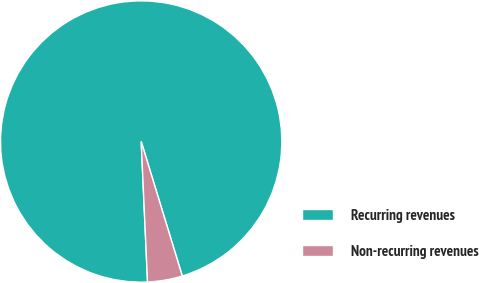Convert chart. <chart><loc_0><loc_0><loc_500><loc_500><pie_chart><fcel>Recurring revenues<fcel>Non-recurring revenues<nl><fcel>96.0%<fcel>4.0%<nl></chart> 